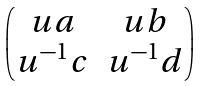<formula> <loc_0><loc_0><loc_500><loc_500>\begin{pmatrix} u a & u b \\ u ^ { - 1 } c & u ^ { - 1 } d \end{pmatrix}</formula> 